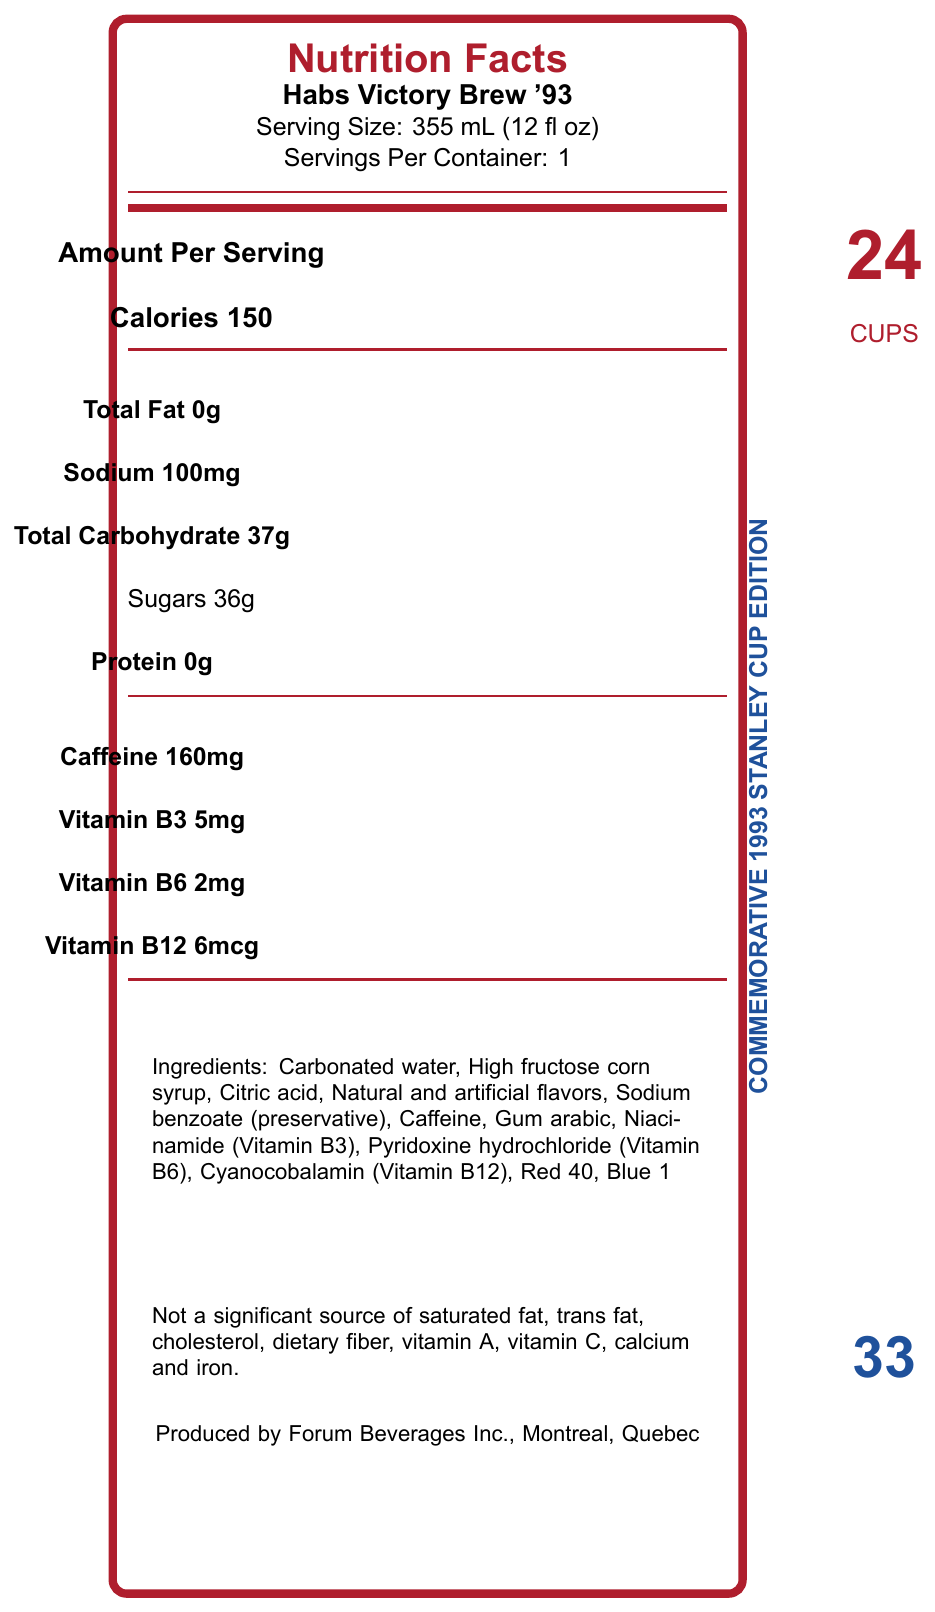when was the Canadiens' 24th Stanley Cup victory? The drink name is "Habs Victory Brew '93", which commemorates this event, and it explicitly mentions the 24th Stanley Cup victory.
Answer: 1993 how much caffeine is in one serving of the Habs Victory Brew '93? The nutrition label specifies that each serving contains 160mg of caffeine.
Answer: 160mg what are the three B-vitamins listed on the label? The label mentions Vitamin B3 (Niacinamide), Vitamin B6 (Pyridoxine hydrochloride), and Vitamin B12 (Cyanocobalamin).
Answer: Vitamin B3, B6, and B12 what is the serving size of the Habs Victory Brew '93? The serving size is explicitly listed as "355 mL (12 fl oz)" on the label.
Answer: 355 mL (12 fl oz) what is the flavor inspiration behind the Habs Victory Brew '93? The historical notes specify that the flavor was inspired by the team's victory champagne.
Answer: Team's victory champagne which collector's item signifier is present on the can? A. The team's logo B. Larry Robinson's number 19 C. Patrick Roy's number 33 D. Guy Lafleur's number 10 The can features Patrick Roy's number 33 as part of its special features.
Answer: C. Patrick Roy's number 33 according to the label, which nutrient is not a significant source in the drink? A. Vitamin A B. Vitamin C C. Calcium D. All of the above The disclaimer section says it is not a significant source of saturated fat, trans fat, cholesterol, dietary fiber, vitamin A, vitamin C, calcium, and iron.
Answer: D. All of the above is there any protein in the Habs Victory Brew '93? The label specifies that the beverage contains 0g of protein.
Answer: No does the Habs Victory Brew '93 contain artificial sweeteners? The ingredients list does not mention any artificial sweeteners; it uses high fructose corn syrup instead.
Answer: No summarize the main idea of the Nutrition Facts label for the Habs Victory Brew '93. The label's main idea is to present nutritional details, special commemorative features, and historical notes of the Habs Victory Brew '93.
Answer: The Nutrition Facts label for the Habs Victory Brew '93 provides detailed information about the nutrient content per 355 mL serving, including 150 calories, 160mg of caffeine, and B-vitamins. The drink commemorates the Montreal Canadiens' 1993 Stanley Cup victory. Special features include a limited edition can with Patrick Roy's number, and ingredients range from carbonated water to color additives. what was the ranking of the Canadiens' 1993 playoff run in the season standings? The document does not provide any specific ranking information of the Canadiens' 1993 playoff run in the season standings.
Answer: Not enough information 